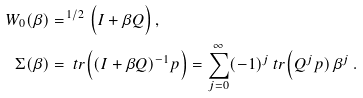Convert formula to latex. <formula><loc_0><loc_0><loc_500><loc_500>W _ { 0 } ( \beta ) & = ^ { \, 1 / 2 } \Big ( I + \beta Q \Big ) \, , \\ \Sigma ( \beta ) & = \ t r \Big ( ( I + \beta Q ) ^ { - 1 } p \Big ) = \sum _ { j = 0 } ^ { \infty } ( - 1 ) ^ { j } \ t r \Big ( Q ^ { j } p ) \, \beta ^ { j } \, .</formula> 